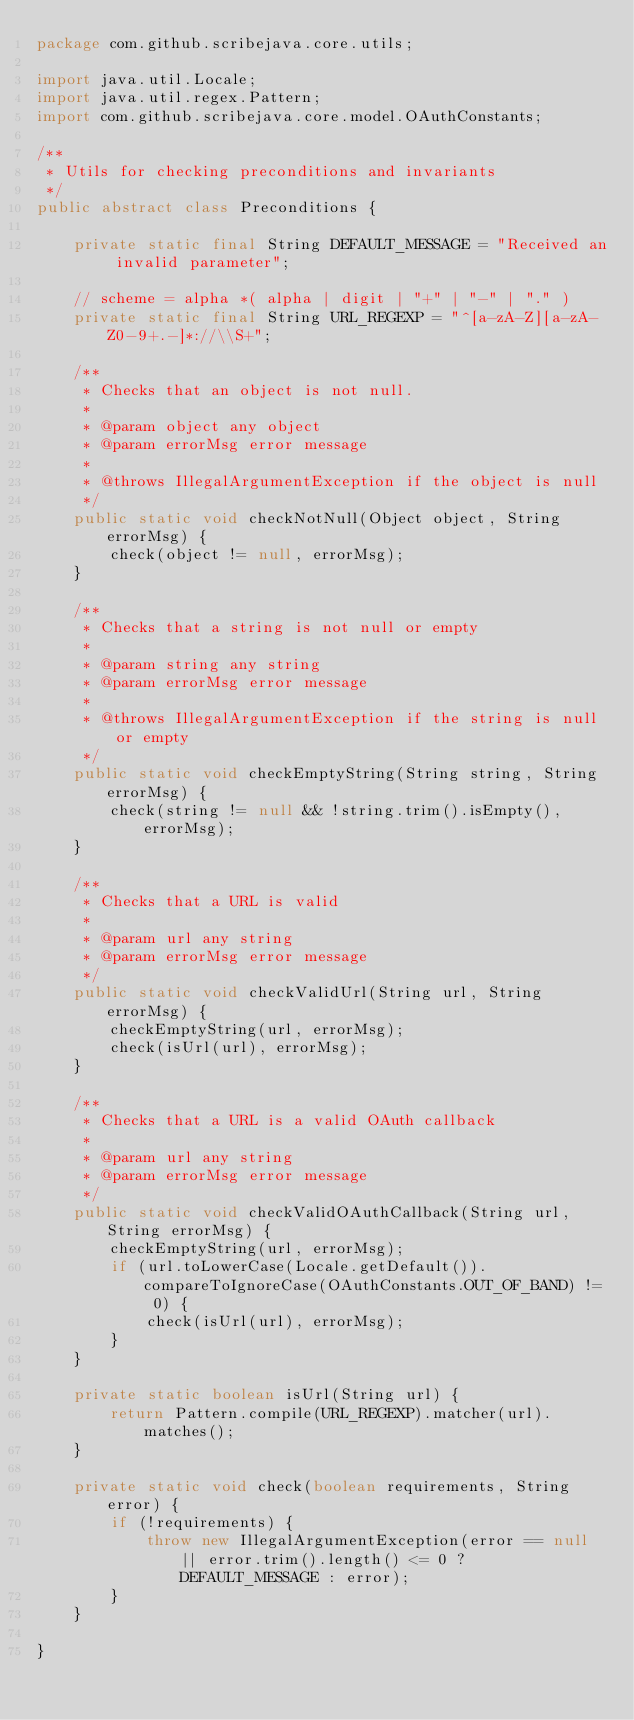Convert code to text. <code><loc_0><loc_0><loc_500><loc_500><_Java_>package com.github.scribejava.core.utils;

import java.util.Locale;
import java.util.regex.Pattern;
import com.github.scribejava.core.model.OAuthConstants;

/**
 * Utils for checking preconditions and invariants
 */
public abstract class Preconditions {

    private static final String DEFAULT_MESSAGE = "Received an invalid parameter";

    // scheme = alpha *( alpha | digit | "+" | "-" | "." )
    private static final String URL_REGEXP = "^[a-zA-Z][a-zA-Z0-9+.-]*://\\S+";

    /**
     * Checks that an object is not null.
     *
     * @param object any object
     * @param errorMsg error message
     *
     * @throws IllegalArgumentException if the object is null
     */
    public static void checkNotNull(Object object, String errorMsg) {
        check(object != null, errorMsg);
    }

    /**
     * Checks that a string is not null or empty
     *
     * @param string any string
     * @param errorMsg error message
     *
     * @throws IllegalArgumentException if the string is null or empty
     */
    public static void checkEmptyString(String string, String errorMsg) {
        check(string != null && !string.trim().isEmpty(), errorMsg);
    }

    /**
     * Checks that a URL is valid
     *
     * @param url any string
     * @param errorMsg error message
     */
    public static void checkValidUrl(String url, String errorMsg) {
        checkEmptyString(url, errorMsg);
        check(isUrl(url), errorMsg);
    }

    /**
     * Checks that a URL is a valid OAuth callback
     *
     * @param url any string
     * @param errorMsg error message
     */
    public static void checkValidOAuthCallback(String url, String errorMsg) {
        checkEmptyString(url, errorMsg);
        if (url.toLowerCase(Locale.getDefault()).compareToIgnoreCase(OAuthConstants.OUT_OF_BAND) != 0) {
            check(isUrl(url), errorMsg);
        }
    }

    private static boolean isUrl(String url) {
        return Pattern.compile(URL_REGEXP).matcher(url).matches();
    }

    private static void check(boolean requirements, String error) {
        if (!requirements) {
            throw new IllegalArgumentException(error == null || error.trim().length() <= 0 ? DEFAULT_MESSAGE : error);
        }
    }

}
</code> 